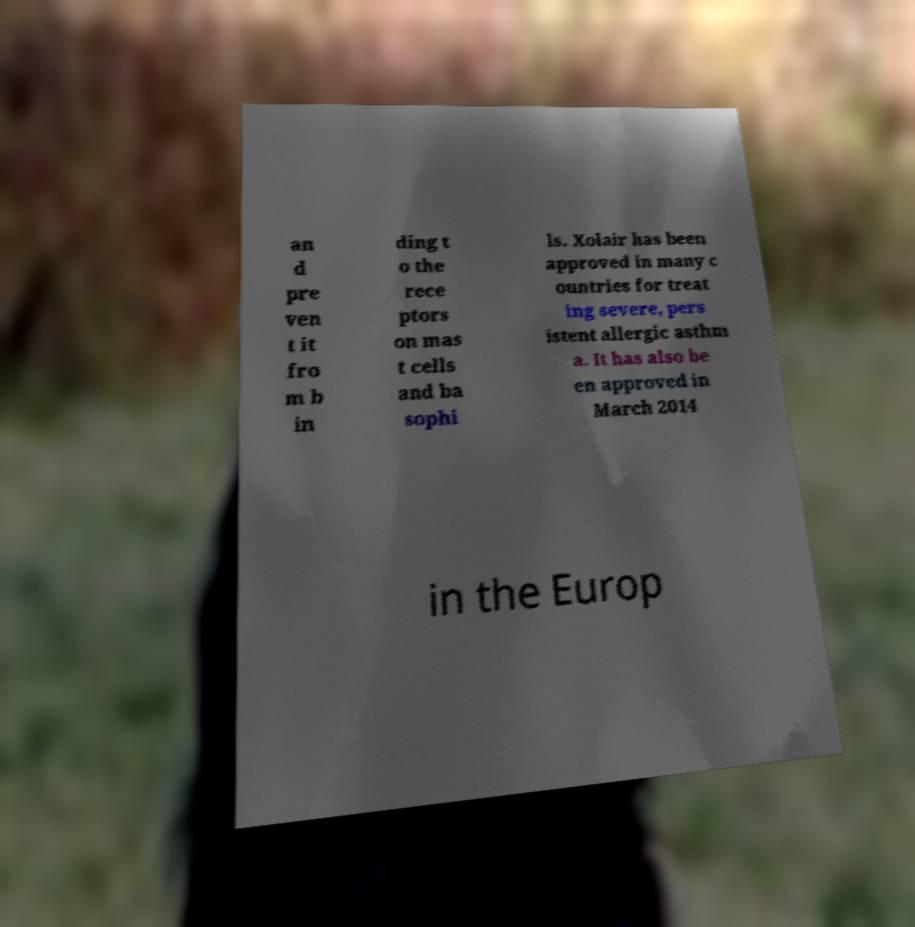Could you assist in decoding the text presented in this image and type it out clearly? an d pre ven t it fro m b in ding t o the rece ptors on mas t cells and ba sophi ls. Xolair has been approved in many c ountries for treat ing severe, pers istent allergic asthm a. It has also be en approved in March 2014 in the Europ 